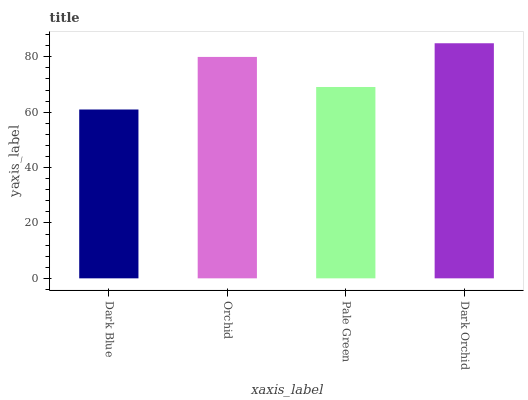Is Dark Blue the minimum?
Answer yes or no. Yes. Is Dark Orchid the maximum?
Answer yes or no. Yes. Is Orchid the minimum?
Answer yes or no. No. Is Orchid the maximum?
Answer yes or no. No. Is Orchid greater than Dark Blue?
Answer yes or no. Yes. Is Dark Blue less than Orchid?
Answer yes or no. Yes. Is Dark Blue greater than Orchid?
Answer yes or no. No. Is Orchid less than Dark Blue?
Answer yes or no. No. Is Orchid the high median?
Answer yes or no. Yes. Is Pale Green the low median?
Answer yes or no. Yes. Is Dark Orchid the high median?
Answer yes or no. No. Is Dark Orchid the low median?
Answer yes or no. No. 